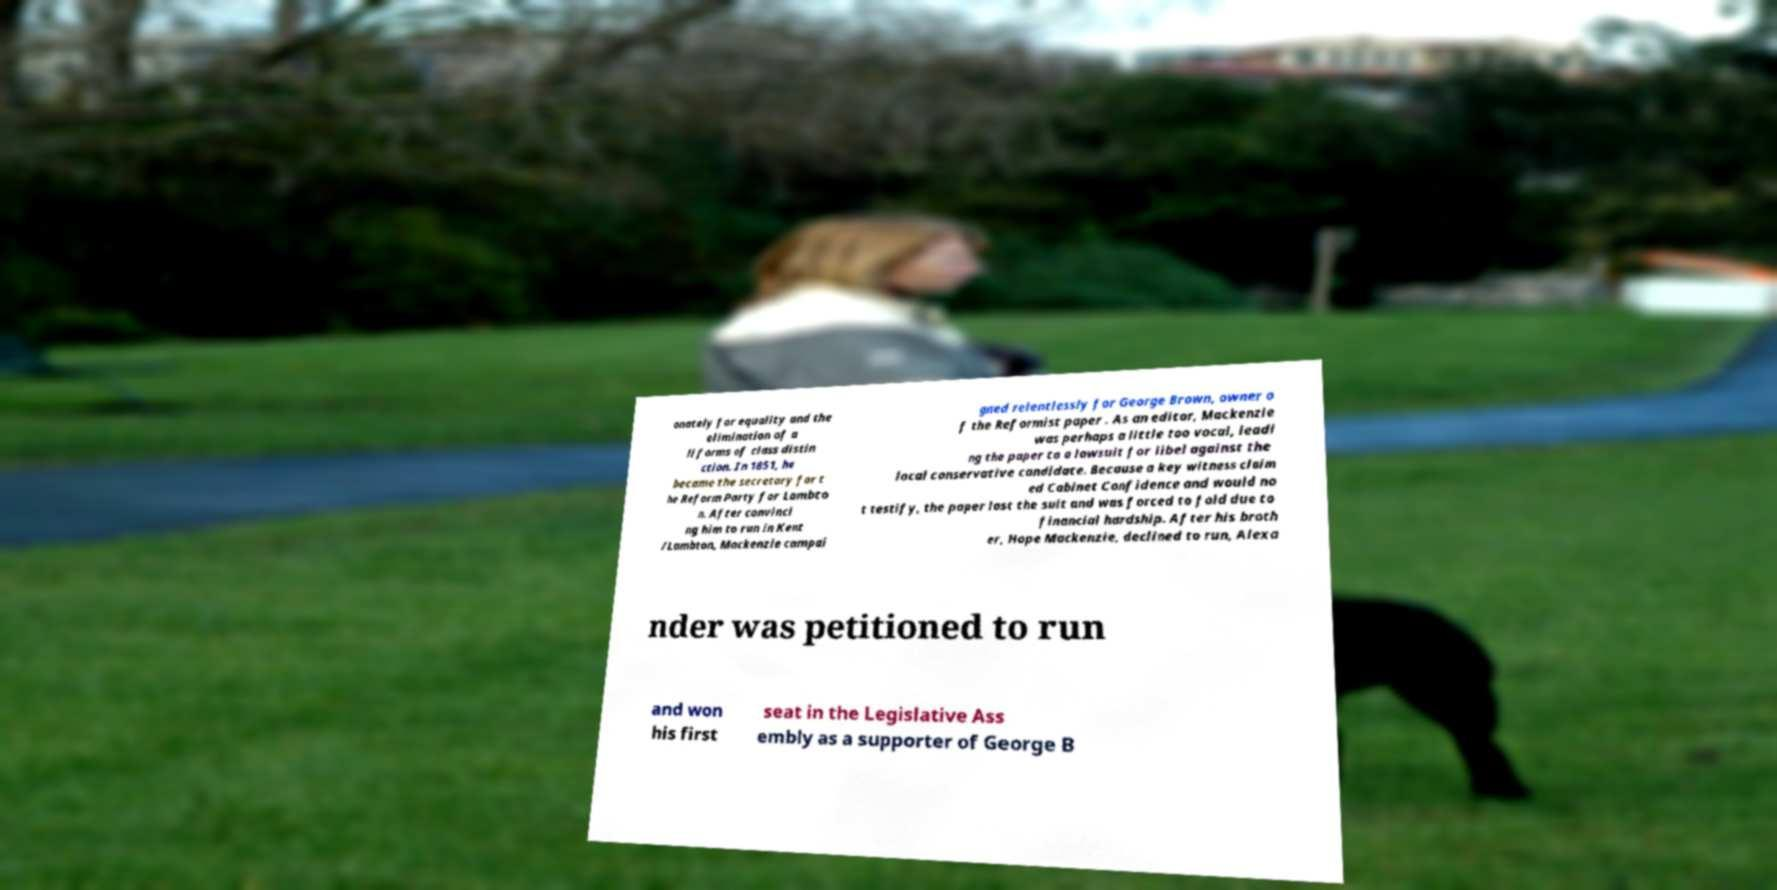Could you assist in decoding the text presented in this image and type it out clearly? onately for equality and the elimination of a ll forms of class distin ction. In 1851, he became the secretary for t he Reform Party for Lambto n. After convinci ng him to run in Kent /Lambton, Mackenzie campai gned relentlessly for George Brown, owner o f the Reformist paper . As an editor, Mackenzie was perhaps a little too vocal, leadi ng the paper to a lawsuit for libel against the local conservative candidate. Because a key witness claim ed Cabinet Confidence and would no t testify, the paper lost the suit and was forced to fold due to financial hardship. After his broth er, Hope Mackenzie, declined to run, Alexa nder was petitioned to run and won his first seat in the Legislative Ass embly as a supporter of George B 